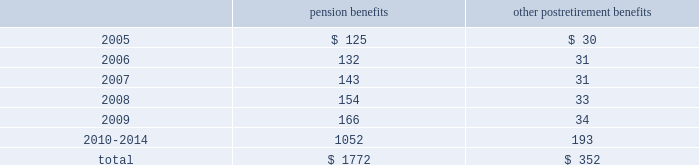Notes to consolidated financial statements ( continued ) 17 .
Pension plans and postretirement health care and life insurance benefit plans ( continued ) benefit payments the table sets forth amounts of benefits expected to be paid over the next ten years from the company 2019s pension and postretirement plans as of december 31 , 2004: .
18 .
Stock compensation plans on may 18 , 2000 , the shareholders of the hartford approved the hartford incentive stock plan ( the 201c2000 plan 201d ) , which replaced the hartford 1995 incentive stock plan ( the 201c1995 plan 201d ) .
The terms of the 2000 plan were substantially similar to the terms of the 1995 plan except that the 1995 plan had an annual award limit and a higher maximum award limit .
Under the 2000 plan , awards may be granted in the form of non-qualified or incentive stock options qualifying under section 422a of the internal revenue code , performance shares or restricted stock , or any combination of the foregoing .
In addition , stock appreciation rights may be granted in connection with all or part of any stock options granted under the 2000 plan .
In december 2004 , the 2000 plan was amended to allow for grants of restricted stock units effective as of january 1 , 2005 .
The aggregate number of shares of stock , which may be awarded , is subject to a maximum limit of 17211837 shares applicable to all awards for the ten-year duration of the 2000 plan .
All options granted have an exercise price equal to the market price of the company 2019s common stock on the date of grant , and an option 2019s maximum term is ten years and two days .
Certain options become exercisable over a three year period commencing one year from the date of grant , while certain other options become exercisable upon the attainment of specified market price appreciation of the company 2019s common shares .
For any year , no individual employee may receive an award of options for more than 1000000 shares .
As of december 31 , 2004 , the hartford had not issued any incentive stock options under the 2000 plan .
Performance awards of common stock granted under the 2000 plan become payable upon the attainment of specific performance goals achieved over a period of not less than one nor more than five years , and the restricted stock granted is subject to a restriction period .
On a cumulative basis , no more than 20% ( 20 % ) of the aggregate number of shares which may be awarded under the 2000 plan are available for performance shares and restricted stock awards .
Also , the maximum award of performance shares for any individual employee in any year is 200000 shares .
In 2004 , 2003 and 2002 , the company granted shares of common stock of 315452 , 333712 and 40852 with weighted average prices of $ 64.93 , $ 38.13 and $ 62.28 , respectively , related to performance share and restricted stock awards .
In 1996 , the company established the hartford employee stock purchase plan ( 201cespp 201d ) .
Under this plan , eligible employees of the hartford may purchase common stock of the company at a 15% ( 15 % ) discount from the lower of the closing market price at the beginning or end of the quarterly offering period .
The company may sell up to 5400000 shares of stock to eligible employees under the espp .
In 2004 , 2003 and 2002 , 345262 , 443467 and 408304 shares were sold , respectively .
The per share weighted average fair value of the discount under the espp was $ 9.31 , $ 11.96 , and $ 11.70 in 2004 , 2003 and 2002 , respectively .
Additionally , during 1997 , the hartford established employee stock purchase plans for certain employees of the company 2019s international subsidiaries .
Under these plans , participants may purchase common stock of the hartford at a fixed price at the end of a three-year period .
The activity under these programs is not material. .
What was the average shares the company granted of common stock from 2002 to 2004? 
Computations: ((40852 + (315452 + 333712)) / 3)
Answer: 230005.33333. 